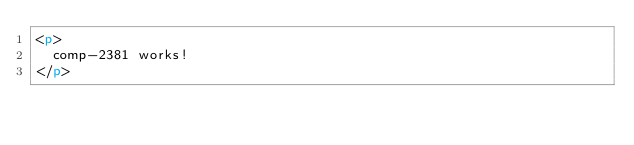Convert code to text. <code><loc_0><loc_0><loc_500><loc_500><_HTML_><p>
  comp-2381 works!
</p>
</code> 